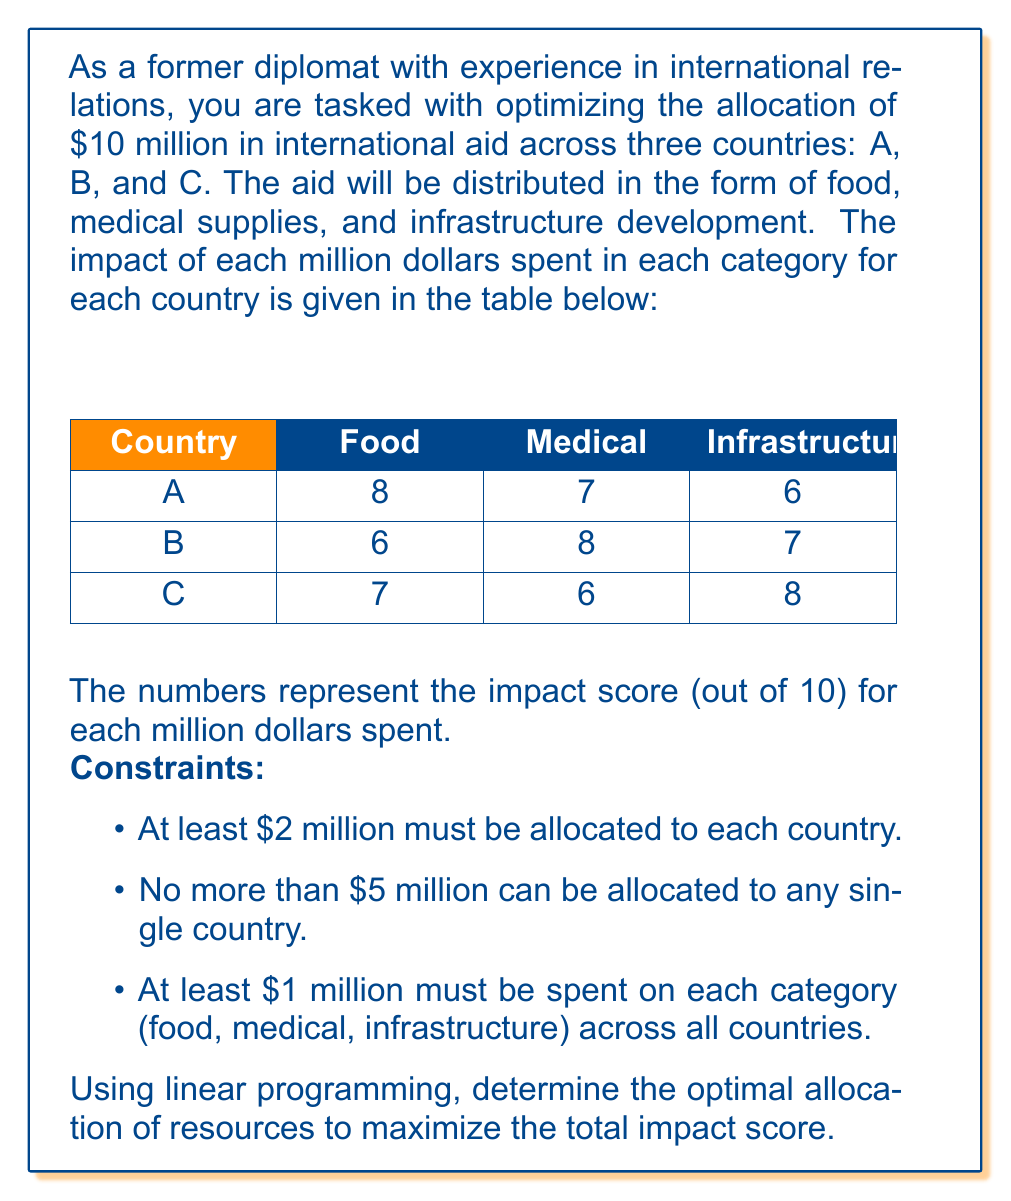Give your solution to this math problem. To solve this problem using linear programming, we need to define our variables, objective function, and constraints.

Let's define our variables:
$x_{ij}$ = millions of dollars allocated to country $i$ in category $j$
where $i \in \{A, B, C\}$ and $j \in \{F, M, I\}$ (Food, Medical, Infrastructure)

Objective function:
Maximize $Z = 8x_{AF} + 7x_{AM} + 6x_{AI} + 6x_{BF} + 8x_{BM} + 7x_{BI} + 7x_{CF} + 6x_{CM} + 8x_{CI}$

Constraints:
1. Total budget: $\sum_{i,j} x_{ij} = 10$

2. Minimum allocation per country:
   $x_{AF} + x_{AM} + x_{AI} \geq 2$
   $x_{BF} + x_{BM} + x_{BI} \geq 2$
   $x_{CF} + x_{CM} + x_{CI} \geq 2$

3. Maximum allocation per country:
   $x_{AF} + x_{AM} + x_{AI} \leq 5$
   $x_{BF} + x_{BM} + x_{BI} \leq 5$
   $x_{CF} + x_{CM} + x_{CI} \leq 5$

4. Minimum allocation per category:
   $x_{AF} + x_{BF} + x_{CF} \geq 1$
   $x_{AM} + x_{BM} + x_{CM} \geq 1$
   $x_{AI} + x_{BI} + x_{CI} \geq 1$

5. Non-negativity:
   $x_{ij} \geq 0$ for all $i$ and $j$

Using a linear programming solver (e.g., Simplex method), we can find the optimal solution:

$x_{AF} = 2, x_{AM} = 0, x_{AI} = 0$
$x_{BF} = 0, x_{BM} = 3, x_{BI} = 0$
$x_{CF} = 0, x_{CM} = 0, x_{CI} = 5$

This allocation gives a maximum impact score of:

$Z = 8(2) + 7(0) + 6(0) + 6(0) + 8(3) + 7(0) + 7(0) + 6(0) + 8(5) = 16 + 24 + 40 = 80$
Answer: The optimal allocation of resources is:
Country A: $2 million for food
Country B: $3 million for medical supplies
Country C: $5 million for infrastructure

This allocation maximizes the total impact score at 80. 